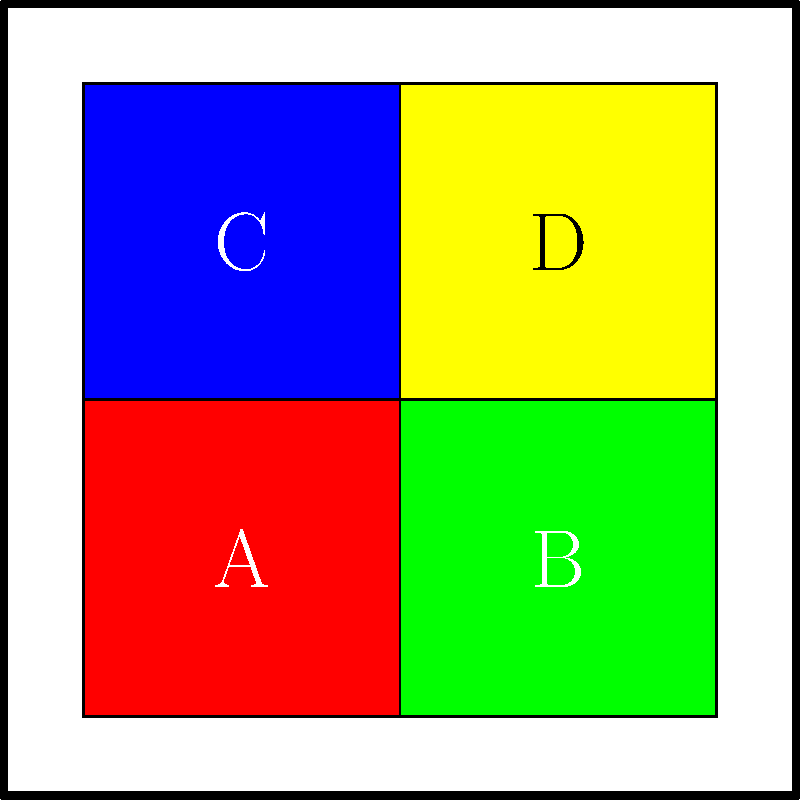In the given comic panel layout, which pair of color blocks represents complementary colors? To identify complementary color schemes, we need to follow these steps:

1. Recognize the colors in each block:
   A: Red
   B: Green
   C: Blue
   D: Yellow

2. Recall the color wheel and complementary color pairs:
   - Red and Green are complementary
   - Blue and Orange are complementary
   - Yellow and Purple are complementary

3. Analyze the color combinations in the layout:
   - A (Red) and B (Green) are complementary
   - C (Blue) and D (Yellow) are not complementary
   - A (Red) and C (Blue) are not complementary
   - B (Green) and D (Yellow) are not complementary

4. Identify the only pair that represents complementary colors:
   A (Red) and B (Green) form a complementary color scheme.

Therefore, the pair of color blocks that represents complementary colors is A and B.
Answer: A and B 